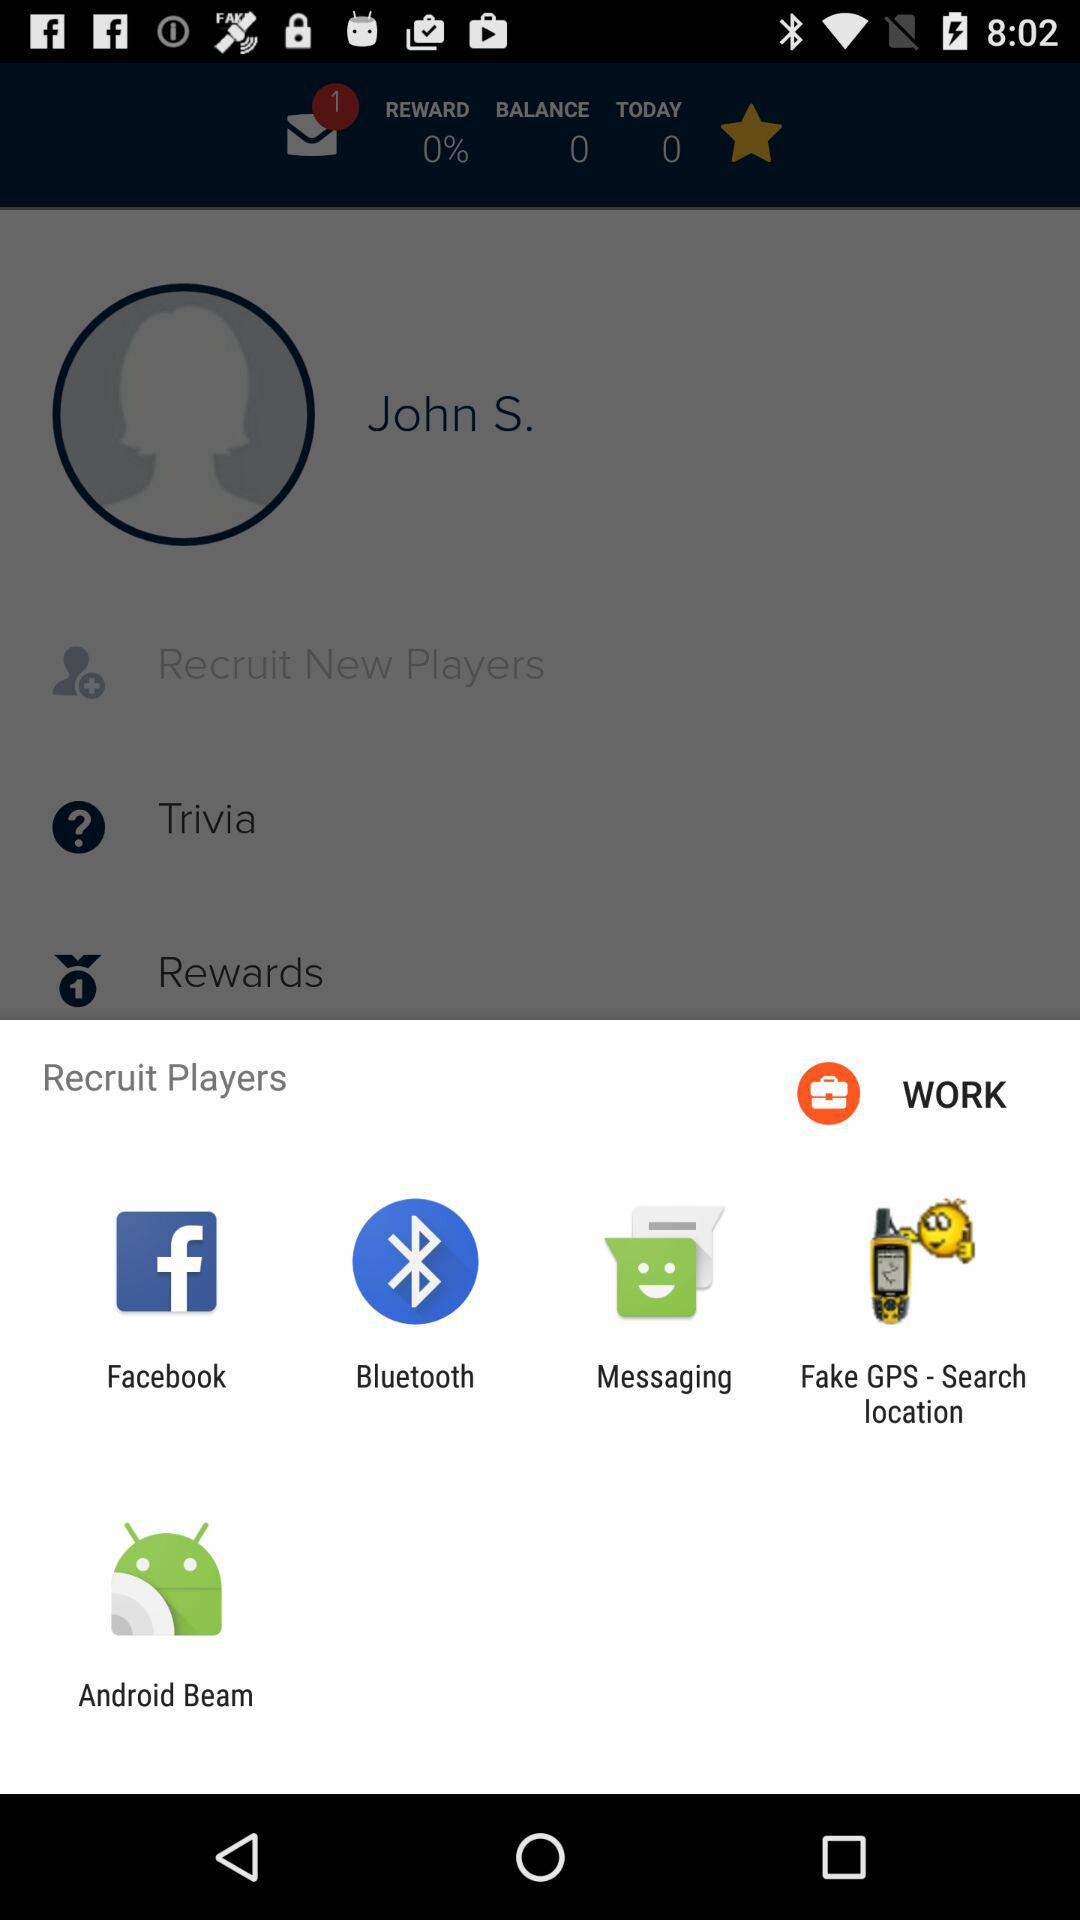What is the percentage of the reward compared to the balance?
Answer the question using a single word or phrase. 0% 